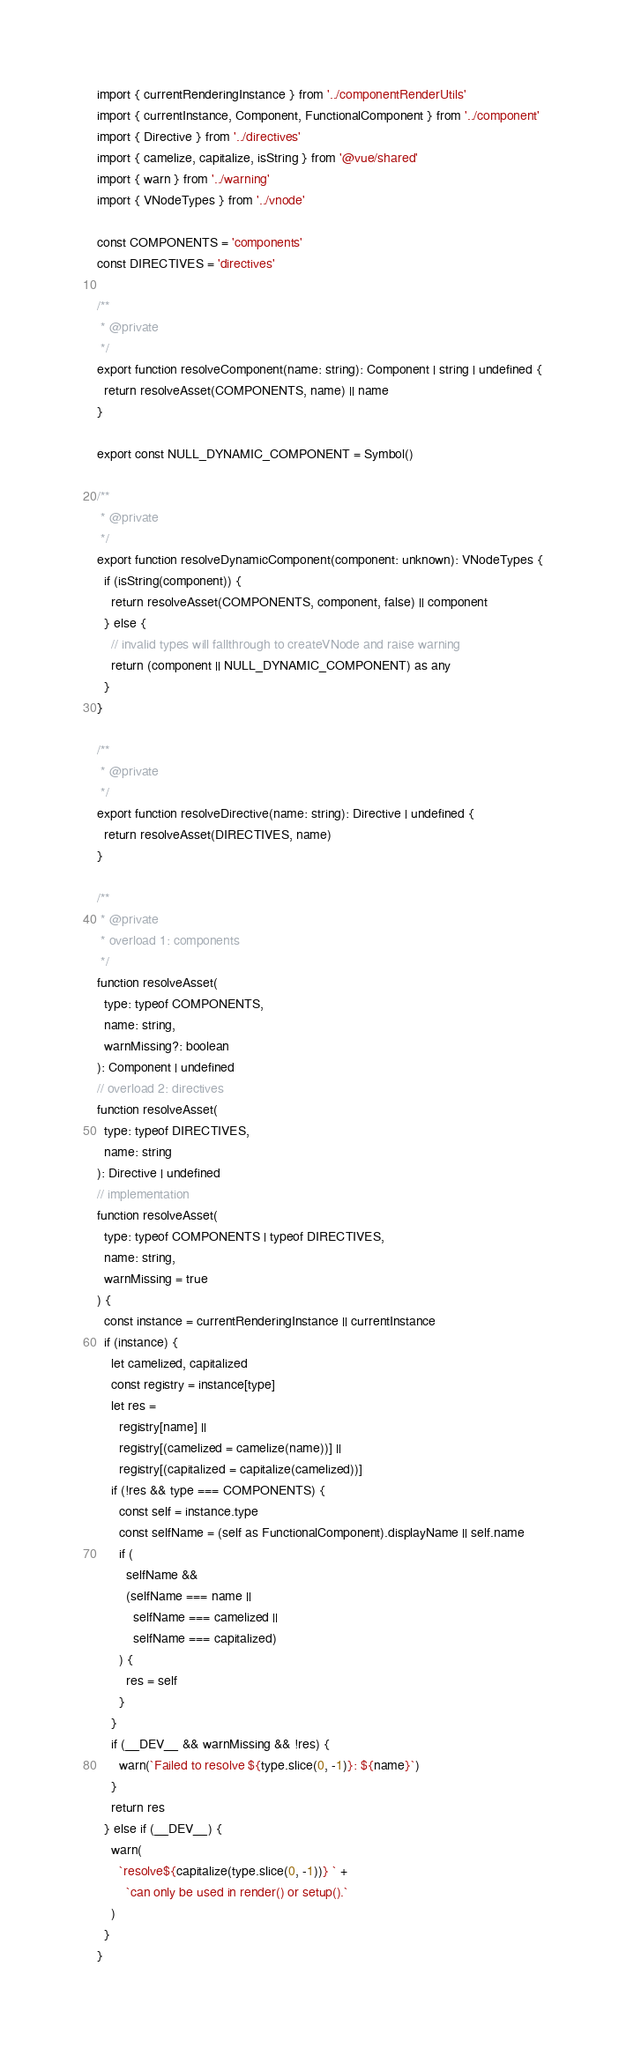Convert code to text. <code><loc_0><loc_0><loc_500><loc_500><_TypeScript_>import { currentRenderingInstance } from '../componentRenderUtils'
import { currentInstance, Component, FunctionalComponent } from '../component'
import { Directive } from '../directives'
import { camelize, capitalize, isString } from '@vue/shared'
import { warn } from '../warning'
import { VNodeTypes } from '../vnode'

const COMPONENTS = 'components'
const DIRECTIVES = 'directives'

/**
 * @private
 */
export function resolveComponent(name: string): Component | string | undefined {
  return resolveAsset(COMPONENTS, name) || name
}

export const NULL_DYNAMIC_COMPONENT = Symbol()

/**
 * @private
 */
export function resolveDynamicComponent(component: unknown): VNodeTypes {
  if (isString(component)) {
    return resolveAsset(COMPONENTS, component, false) || component
  } else {
    // invalid types will fallthrough to createVNode and raise warning
    return (component || NULL_DYNAMIC_COMPONENT) as any
  }
}

/**
 * @private
 */
export function resolveDirective(name: string): Directive | undefined {
  return resolveAsset(DIRECTIVES, name)
}

/**
 * @private
 * overload 1: components
 */
function resolveAsset(
  type: typeof COMPONENTS,
  name: string,
  warnMissing?: boolean
): Component | undefined
// overload 2: directives
function resolveAsset(
  type: typeof DIRECTIVES,
  name: string
): Directive | undefined
// implementation
function resolveAsset(
  type: typeof COMPONENTS | typeof DIRECTIVES,
  name: string,
  warnMissing = true
) {
  const instance = currentRenderingInstance || currentInstance
  if (instance) {
    let camelized, capitalized
    const registry = instance[type]
    let res =
      registry[name] ||
      registry[(camelized = camelize(name))] ||
      registry[(capitalized = capitalize(camelized))]
    if (!res && type === COMPONENTS) {
      const self = instance.type
      const selfName = (self as FunctionalComponent).displayName || self.name
      if (
        selfName &&
        (selfName === name ||
          selfName === camelized ||
          selfName === capitalized)
      ) {
        res = self
      }
    }
    if (__DEV__ && warnMissing && !res) {
      warn(`Failed to resolve ${type.slice(0, -1)}: ${name}`)
    }
    return res
  } else if (__DEV__) {
    warn(
      `resolve${capitalize(type.slice(0, -1))} ` +
        `can only be used in render() or setup().`
    )
  }
}
</code> 